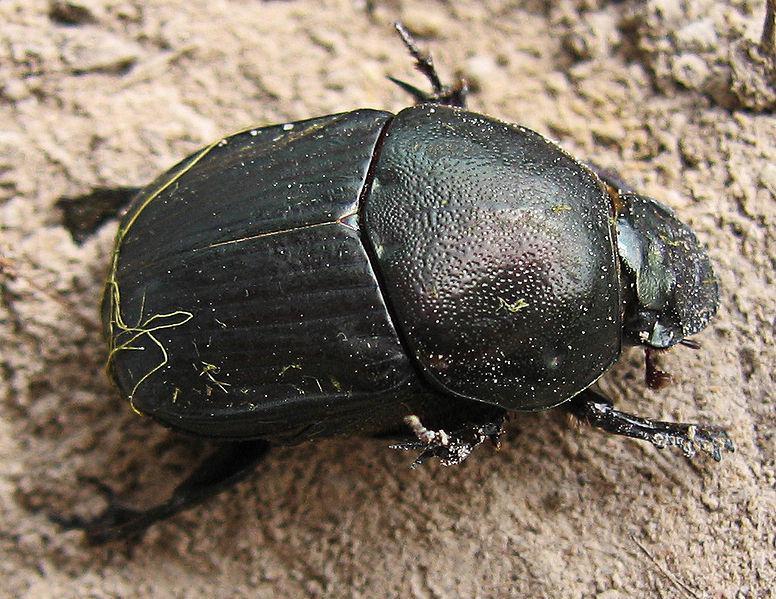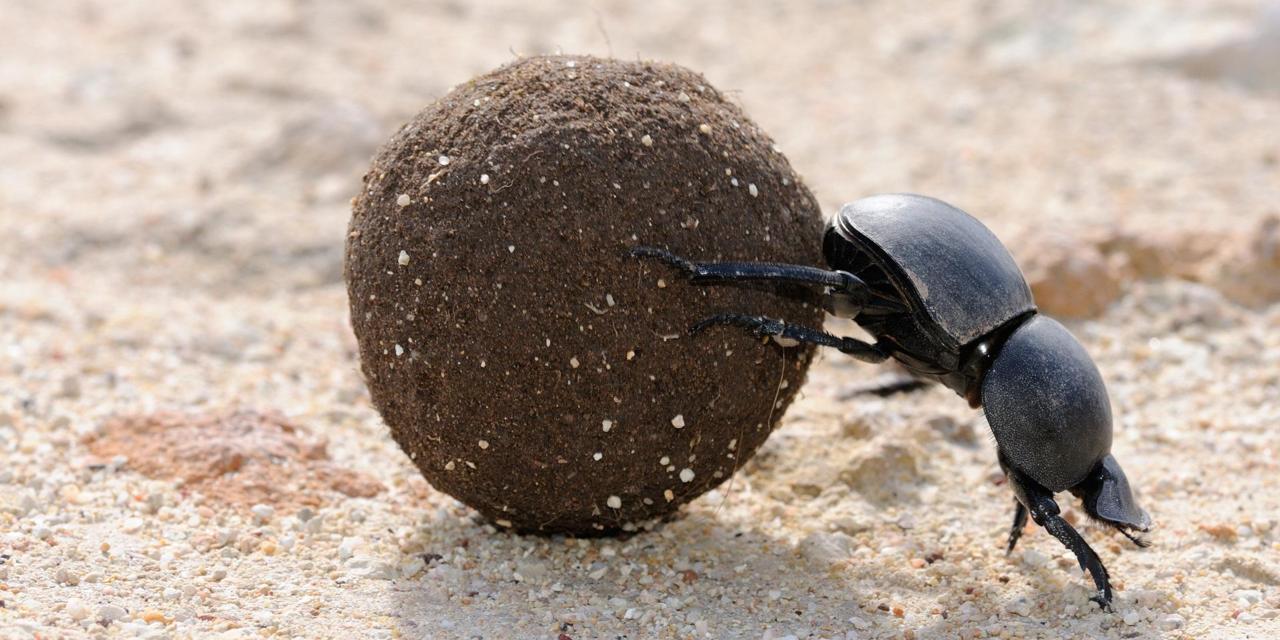The first image is the image on the left, the second image is the image on the right. Analyze the images presented: Is the assertion "The image on the left contains exactly one insect." valid? Answer yes or no. Yes. 